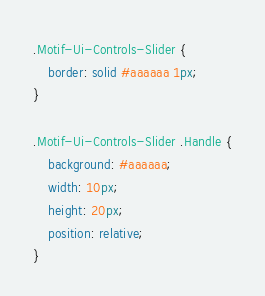Convert code to text. <code><loc_0><loc_0><loc_500><loc_500><_CSS_>.Motif-Ui-Controls-Slider {
    border: solid #aaaaaa 1px;
}

.Motif-Ui-Controls-Slider .Handle {
    background: #aaaaaa;
    width: 10px;
    height: 20px;
    position: relative;
}
</code> 